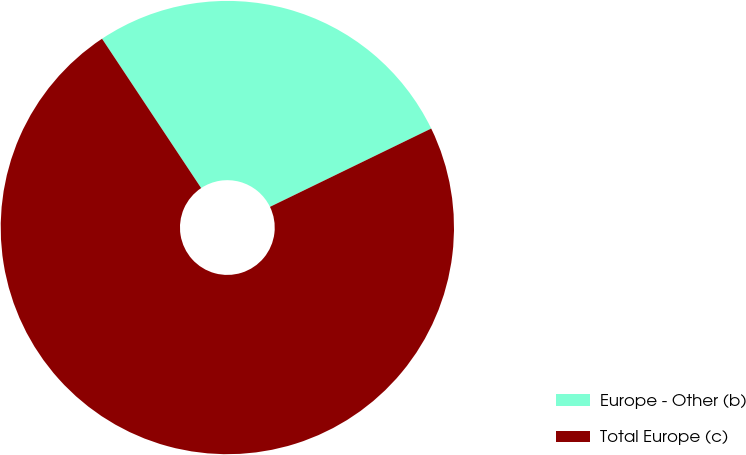Convert chart. <chart><loc_0><loc_0><loc_500><loc_500><pie_chart><fcel>Europe - Other (b)<fcel>Total Europe (c)<nl><fcel>27.13%<fcel>72.87%<nl></chart> 